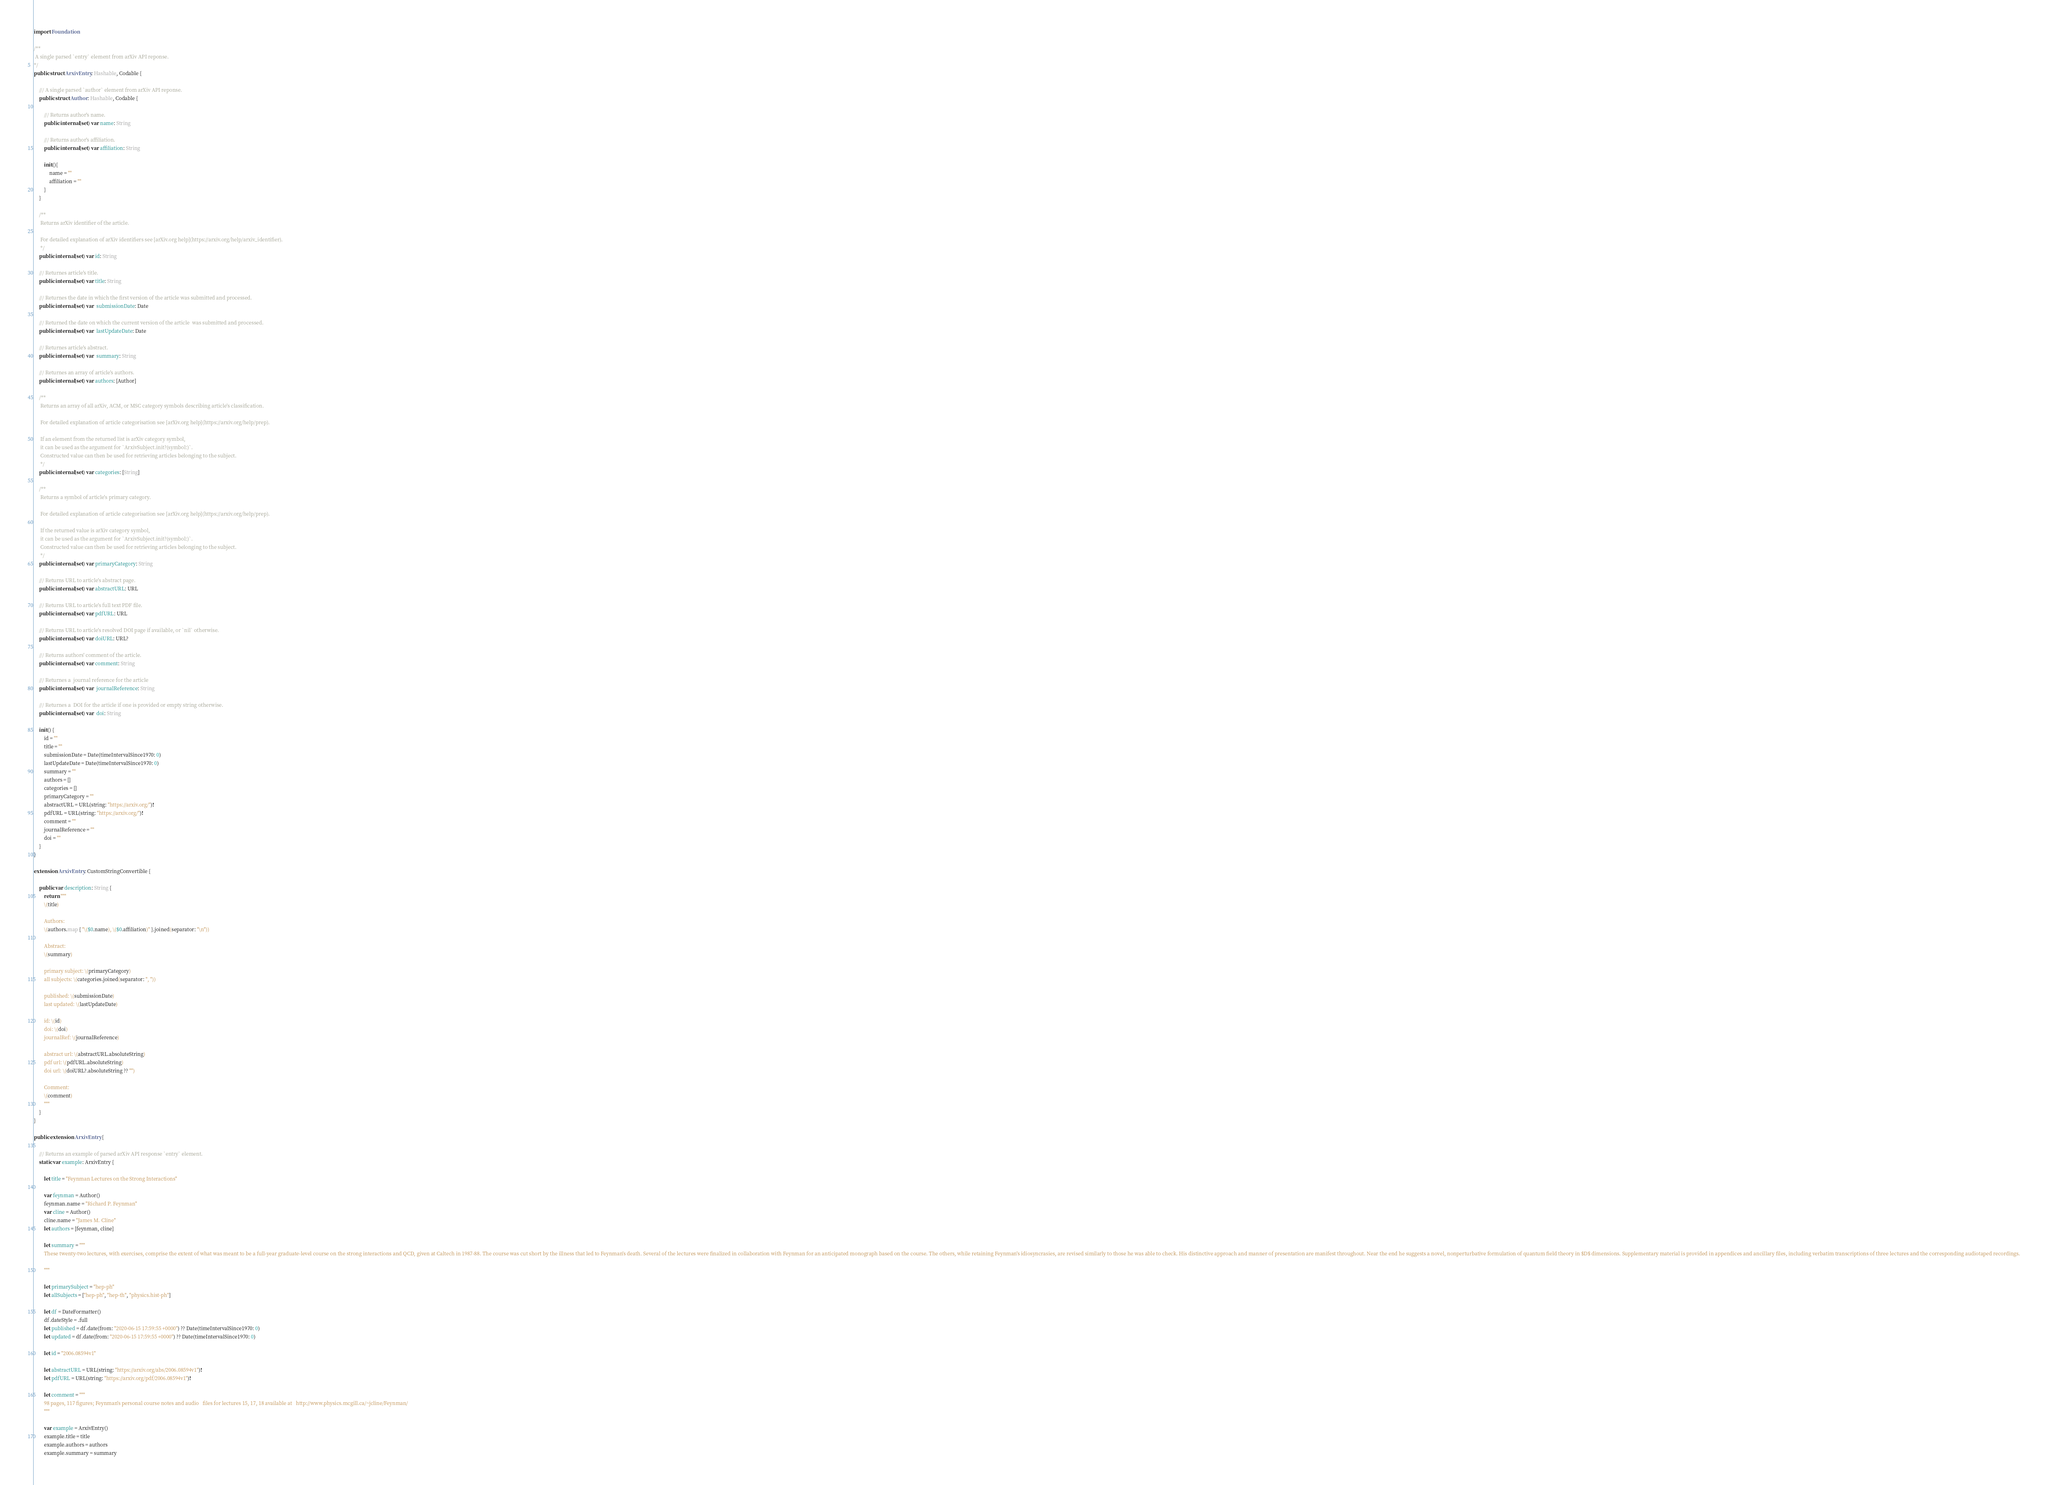<code> <loc_0><loc_0><loc_500><loc_500><_Swift_>
import Foundation

/**
 A single parsed `entry` element from arXiv API reponse.
*/
public struct ArxivEntry: Hashable, Codable {
    
    /// A single parsed `author` element from arXiv API reponse.
    public struct Author: Hashable, Codable {
        
        /// Returns author's name.
        public internal(set) var name: String
        
        /// Returns author's affiliation.
        public internal(set) var affiliation: String
        
        init(){
            name = ""
            affiliation = ""
        }
    }
    
    /**
     Returns arXiv identifier of the article.
     
     For detailed explanation of arXiv identifiers see [arXiv.org help](https://arxiv.org/help/arxiv_identifier).
     */
    public internal(set) var id: String
    
    /// Returnes article's title.
    public internal(set) var title: String
    
    /// Returnes the date in which the first version of the article was submitted and processed.
    public internal(set) var  submissionDate: Date
    
    /// Returned the date on which the current version of the article  was submitted and processed.
    public internal(set) var  lastUpdateDate: Date
    
    /// Returnes article's abstract.
    public internal(set) var  summary: String
    
    /// Returnes an array of article's authors.
    public internal(set) var authors: [Author]
    
    /**
     Returns an array of all arXiv, ACM, or MSC category symbols describing article's classification.
     
     For detailed explanation of article categorisation see [arXiv.org help](https://arxiv.org/help/prep).
     
     If an element from the returned list is arXiv category symbol,
     it can be used as the argument for `ArxivSubject.init?(symbol:)`.
     Constructed value can then be used for retrieving articles belonging to the subject.
     */
    public internal(set) var categories: [String]
    
    /**
     Returns a symbol of article's primary category.
     
     For detailed explanation of article categorisation see [arXiv.org help](https://arxiv.org/help/prep).
     
     If the returned value is arXiv category symbol,
     it can be used as the argument for `ArxivSubject.init?(symbol:)`.
     Constructed value can then be used for retrieving articles belonging to the subject.
     */
    public internal(set) var primaryCategory: String
    
    /// Returns URL to article's abstract page.
    public internal(set) var abstractURL: URL
    
    /// Returns URL to article's full text PDF file.
    public internal(set) var pdfURL: URL
    
    /// Returns URL to article's resolved DOI page if available, or `nil` otherwise.
    public internal(set) var doiURL: URL?
    
    /// Returns authors' comment of the article.
    public internal(set) var comment: String
    
    /// Returnes a  journal reference for the article
    public internal(set) var  journalReference: String
    
    /// Returnes a  DOI for the article if one is provided or empty string otherwise.
    public internal(set) var  doi: String
    
    init() {
        id = ""
        title = ""
        submissionDate = Date(timeIntervalSince1970: 0)
        lastUpdateDate = Date(timeIntervalSince1970: 0)
        summary = ""
        authors = []
        categories = []
        primaryCategory = ""
        abstractURL = URL(string: "https://arxiv.org/")!
        pdfURL = URL(string: "https://arxiv.org/")!
        comment = ""
        journalReference = ""
        doi = ""
    }
}

extension ArxivEntry: CustomStringConvertible {
    
    public var description: String {
        return """
        \(title)

        Authors:
        \(authors.map { "\($0.name), \($0.affiliation)" }.joined(separator: "\n"))

        Abstract:
        \(summary)

        primary subject: \(primaryCategory)
        all subjects: \(categories.joined(separator: ", "))

        published: \(submissionDate)
        last updated: \(lastUpdateDate)

        id: \(id)
        doi: \(doi)
        journalRef: \(journalReference)

        abstract url: \(abstractURL.absoluteString)
        pdf url: \(pdfURL.absoluteString)
        doi url: \(doiURL?.absoluteString ?? "")

        Comment:
        \(comment)
        """
    }
}

public extension ArxivEntry {
    
    /// Returns an example of parsed arXiv API response `entry` element.
    static var example: ArxivEntry {

        let title = "Feynman Lectures on the Strong Interactions"

        var feynman = Author()
        feynman.name = "Richard P. Feynman"
        var cline = Author()
        cline.name = "James M. Cline"
        let authors = [feynman, cline]
        
        let summary = """
        These twenty-two lectures, with exercises, comprise the extent of what was meant to be a full-year graduate-level course on the strong interactions and QCD, given at Caltech in 1987-88. The course was cut short by the illness that led to Feynman's death. Several of the lectures were finalized in collaboration with Feynman for an anticipated monograph based on the course. The others, while retaining Feynman's idiosyncrasies, are revised similarly to those he was able to check. His distinctive approach and manner of presentation are manifest throughout. Near the end he suggests a novel, nonperturbative formulation of quantum field theory in $D$ dimensions. Supplementary material is provided in appendices and ancillary files, including verbatim transcriptions of three lectures and the corresponding audiotaped recordings.
        
        """
        
        let primarySubject = "hep-ph"
        let allSubjects = ["hep-ph", "hep-th", "physics.hist-ph"]
        
        let df = DateFormatter()
        df.dateStyle = .full
        let published = df.date(from: "2020-06-15 17:59:55 +0000") ?? Date(timeIntervalSince1970: 0)
        let updated = df.date(from: "2020-06-15 17:59:55 +0000") ?? Date(timeIntervalSince1970: 0)
        
        let id = "2006.08594v1"
        
        let abstractURL = URL(string: "https://arxiv.org/abs/2006.08594v1")!
        let pdfURL = URL(string: "https://arxiv.org/pdf/2006.08594v1")!
        
        let comment = """
        98 pages, 117 figures; Feynman's personal course notes and audio   files for lectures 15, 17, 18 available at   http://www.physics.mcgill.ca/~jcline/Feynman/
        """
        
        var example = ArxivEntry()
        example.title = title
        example.authors = authors
        example.summary = summary</code> 